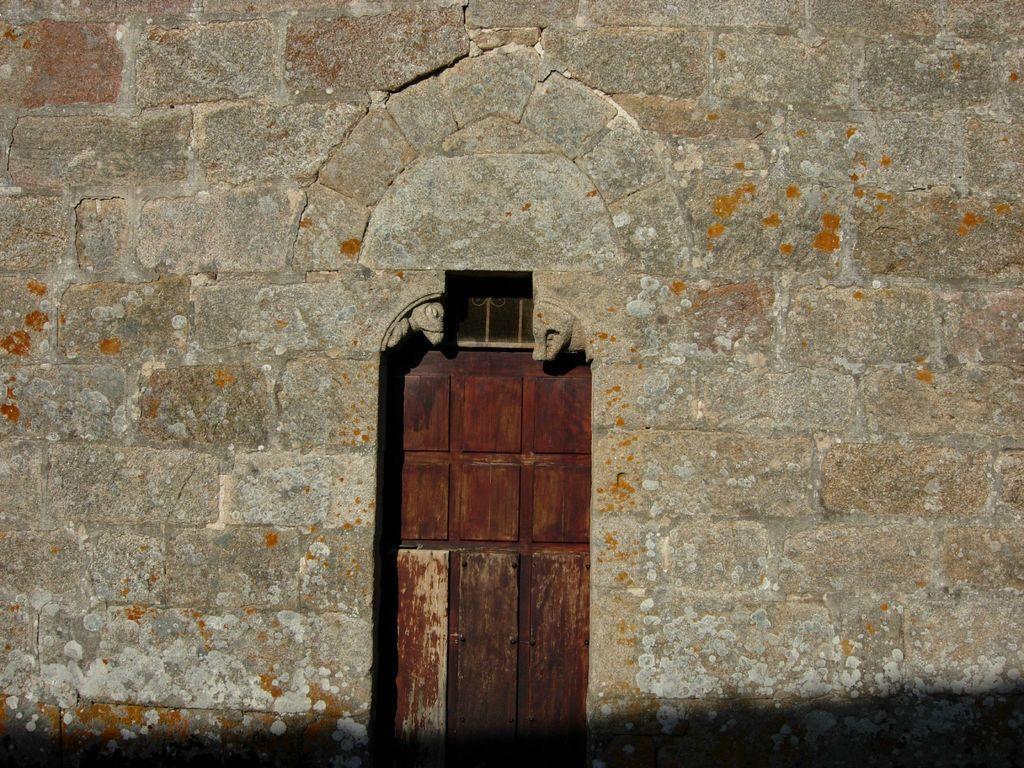Describe this image in one or two sentences. In this image, we can see a door and a wall. 